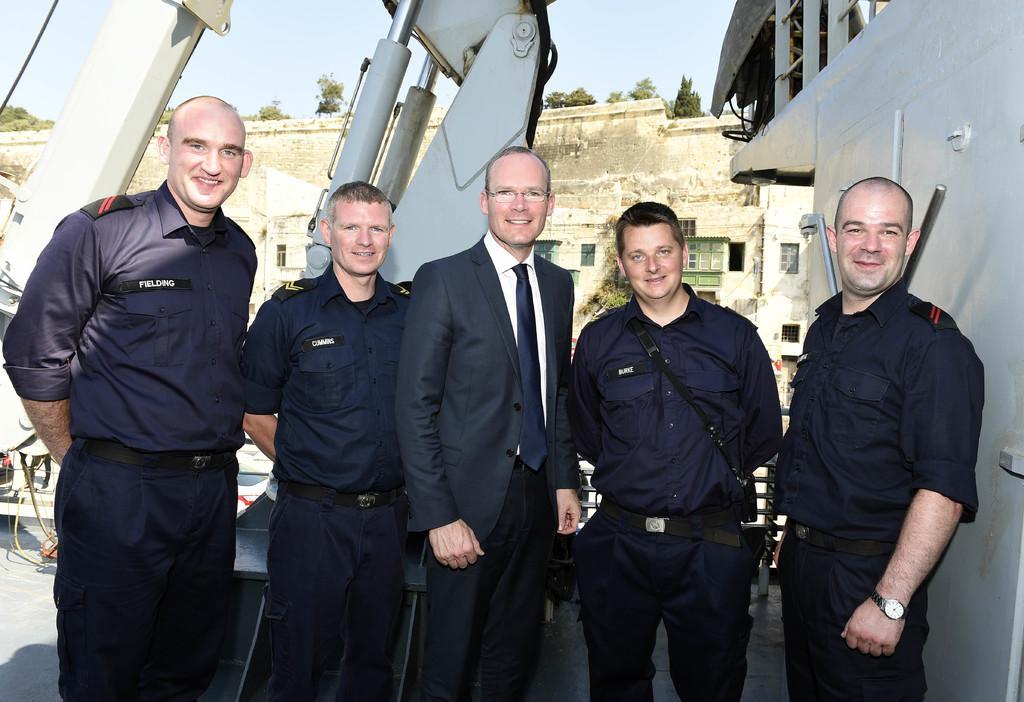Describe this image in one or two sentences. In the image there are five men standing. Behind them there are machines. On the right side of the image there is wall with railing. In the background there is a wall with windows. Behind the wall there are trees. At the top of the image there is sky. 